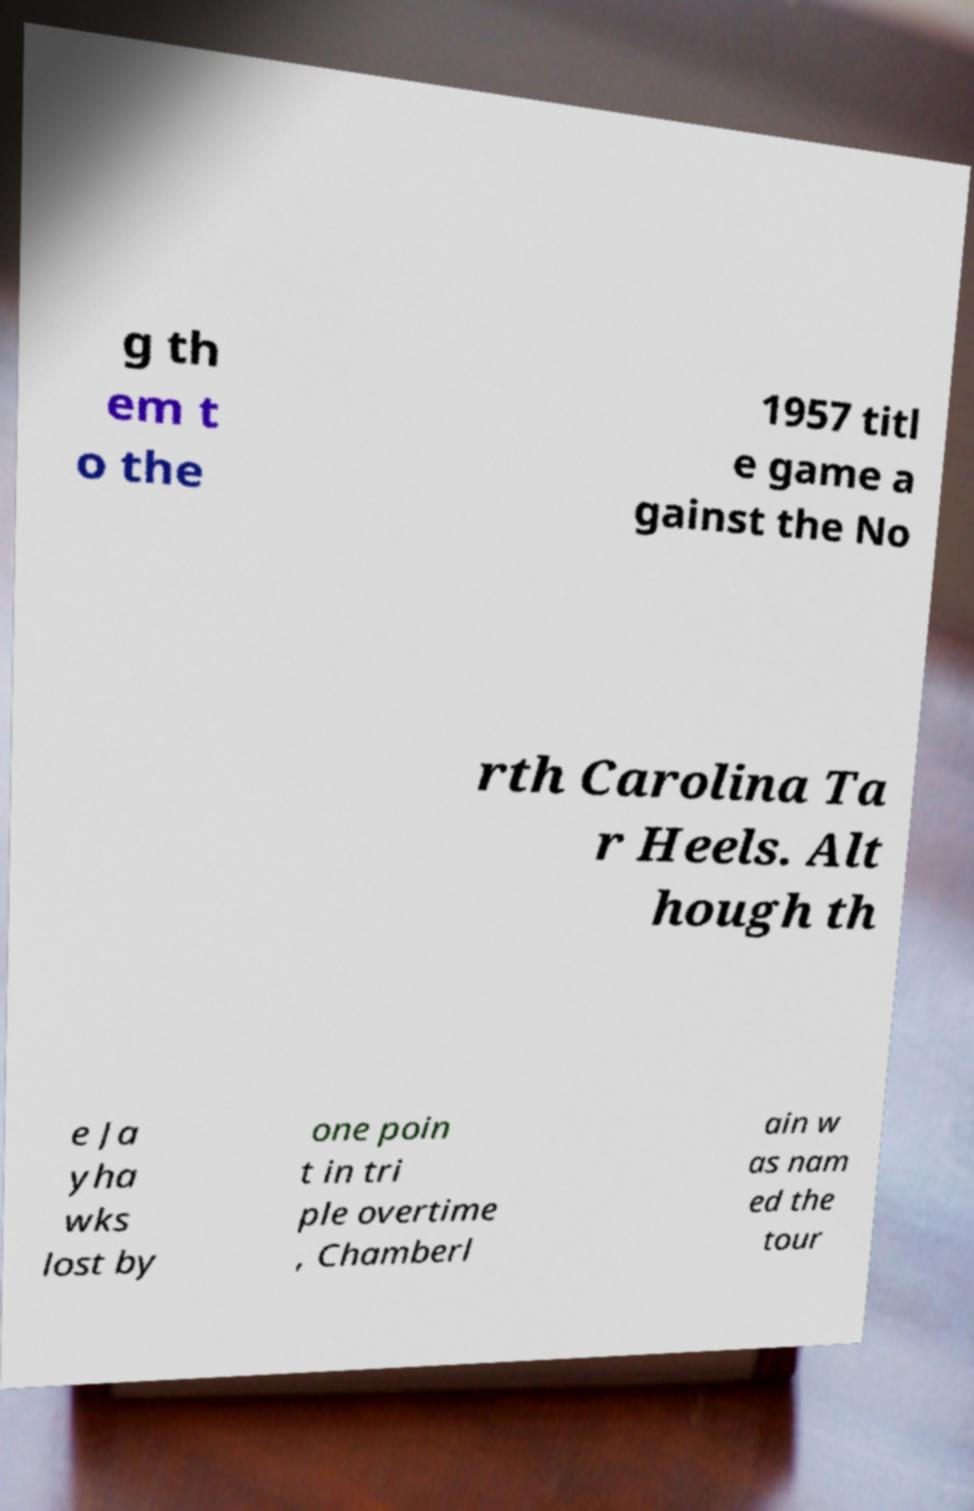What messages or text are displayed in this image? I need them in a readable, typed format. g th em t o the 1957 titl e game a gainst the No rth Carolina Ta r Heels. Alt hough th e Ja yha wks lost by one poin t in tri ple overtime , Chamberl ain w as nam ed the tour 